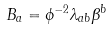<formula> <loc_0><loc_0><loc_500><loc_500>B _ { a } = \phi ^ { - 2 } \lambda _ { a b } \beta ^ { b }</formula> 